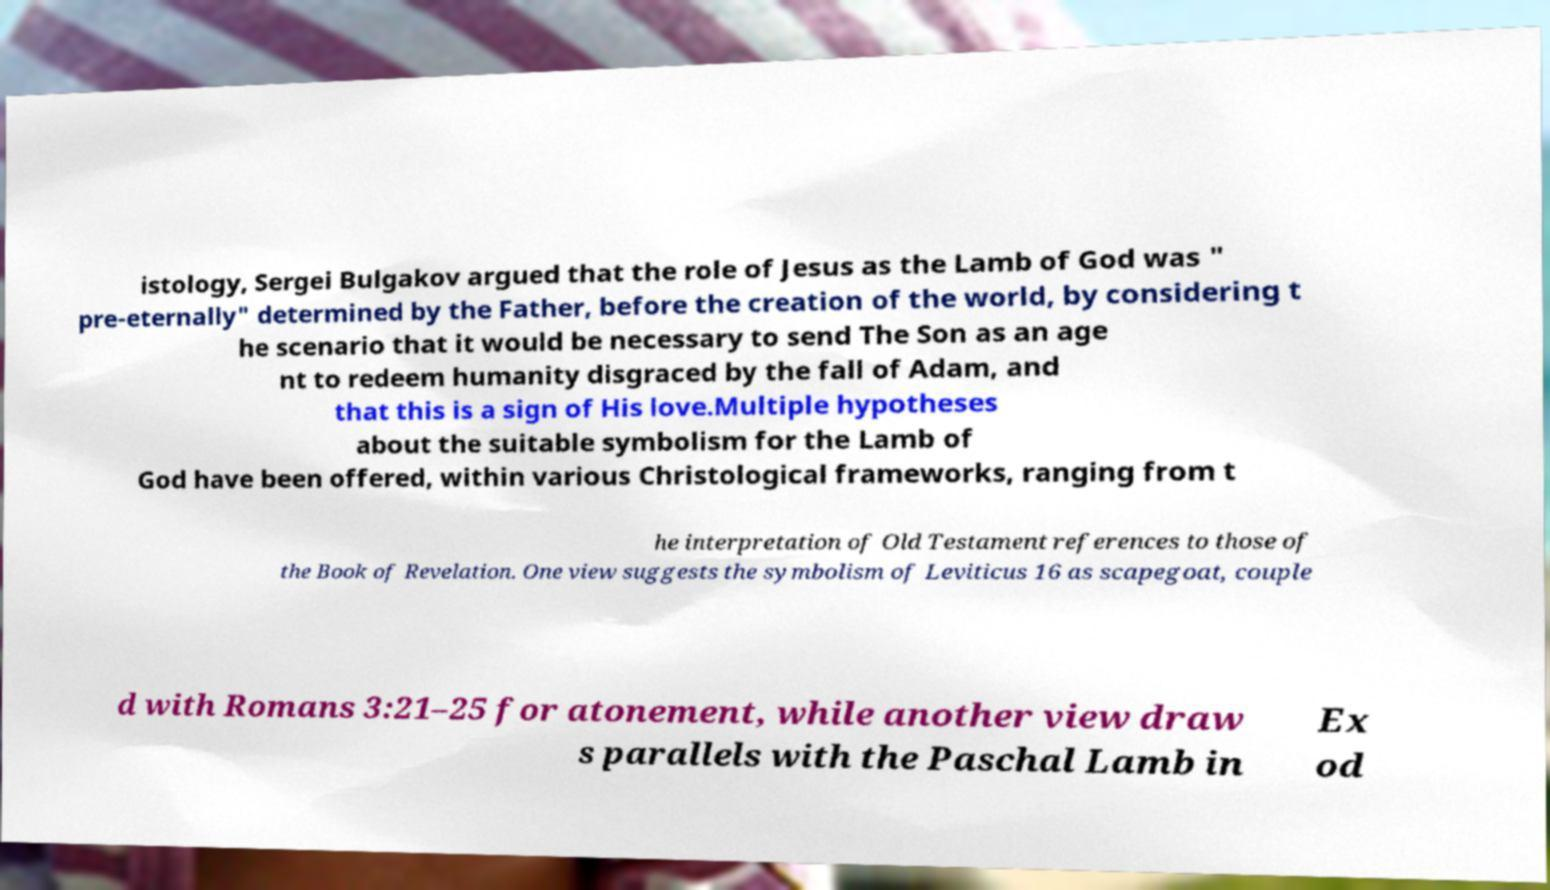What messages or text are displayed in this image? I need them in a readable, typed format. istology, Sergei Bulgakov argued that the role of Jesus as the Lamb of God was " pre-eternally" determined by the Father, before the creation of the world, by considering t he scenario that it would be necessary to send The Son as an age nt to redeem humanity disgraced by the fall of Adam, and that this is a sign of His love.Multiple hypotheses about the suitable symbolism for the Lamb of God have been offered, within various Christological frameworks, ranging from t he interpretation of Old Testament references to those of the Book of Revelation. One view suggests the symbolism of Leviticus 16 as scapegoat, couple d with Romans 3:21–25 for atonement, while another view draw s parallels with the Paschal Lamb in Ex od 